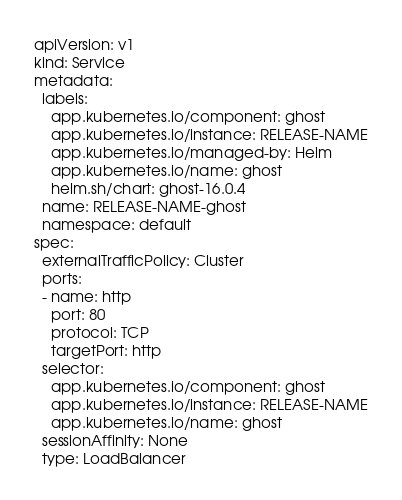<code> <loc_0><loc_0><loc_500><loc_500><_YAML_>apiVersion: v1
kind: Service
metadata:
  labels:
    app.kubernetes.io/component: ghost
    app.kubernetes.io/instance: RELEASE-NAME
    app.kubernetes.io/managed-by: Helm
    app.kubernetes.io/name: ghost
    helm.sh/chart: ghost-16.0.4
  name: RELEASE-NAME-ghost
  namespace: default
spec:
  externalTrafficPolicy: Cluster
  ports:
  - name: http
    port: 80
    protocol: TCP
    targetPort: http
  selector:
    app.kubernetes.io/component: ghost
    app.kubernetes.io/instance: RELEASE-NAME
    app.kubernetes.io/name: ghost
  sessionAffinity: None
  type: LoadBalancer
</code> 